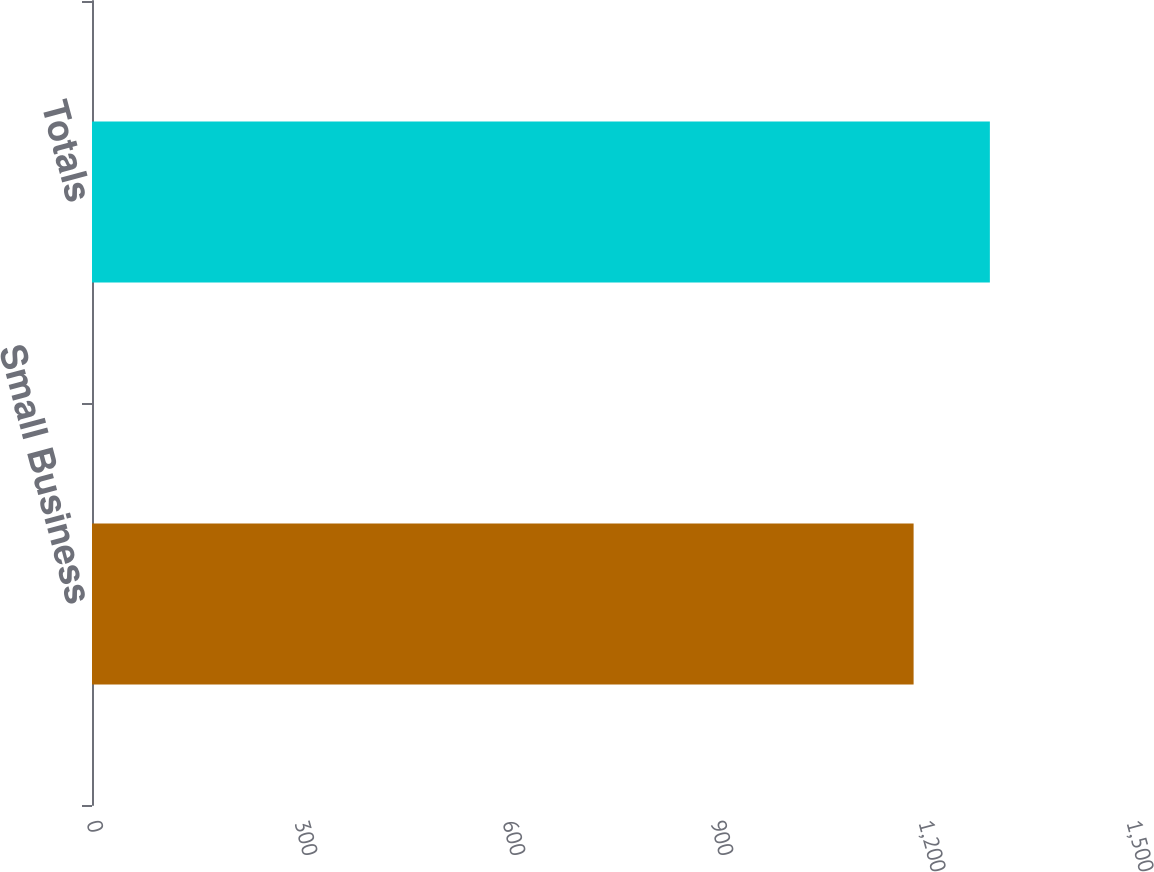Convert chart. <chart><loc_0><loc_0><loc_500><loc_500><bar_chart><fcel>Small Business<fcel>Totals<nl><fcel>1185<fcel>1295<nl></chart> 